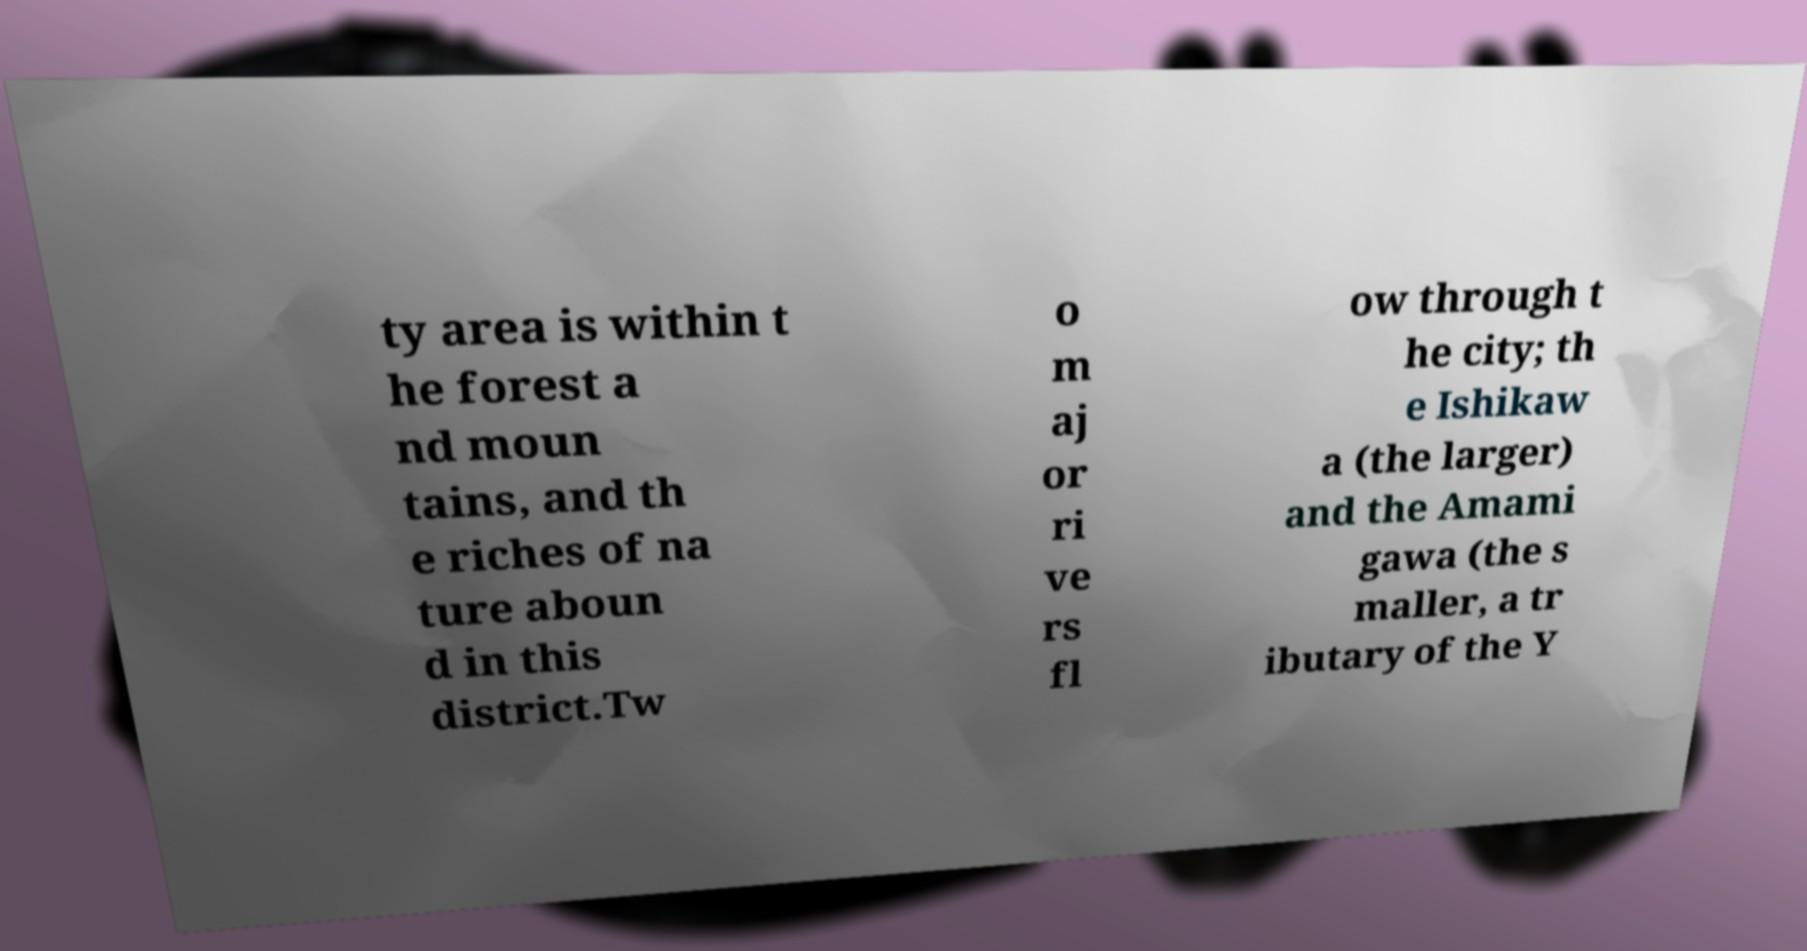Can you accurately transcribe the text from the provided image for me? ty area is within t he forest a nd moun tains, and th e riches of na ture aboun d in this district.Tw o m aj or ri ve rs fl ow through t he city; th e Ishikaw a (the larger) and the Amami gawa (the s maller, a tr ibutary of the Y 